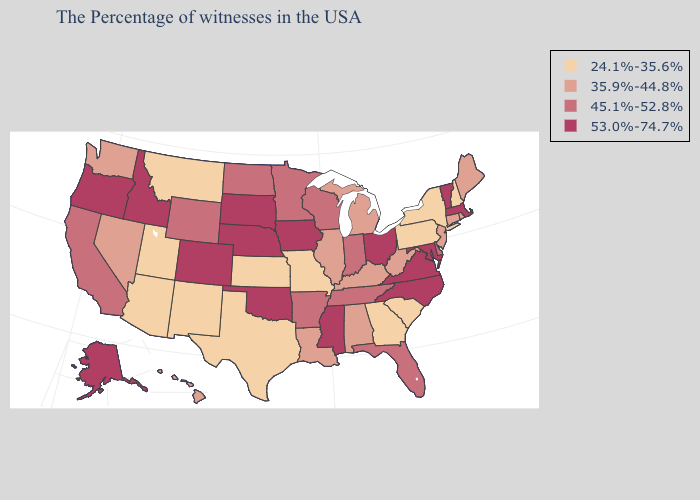What is the value of South Carolina?
Give a very brief answer. 24.1%-35.6%. What is the highest value in the USA?
Be succinct. 53.0%-74.7%. Does New York have the lowest value in the Northeast?
Keep it brief. Yes. Name the states that have a value in the range 45.1%-52.8%?
Quick response, please. Delaware, Florida, Indiana, Tennessee, Wisconsin, Arkansas, Minnesota, North Dakota, Wyoming, California. What is the lowest value in states that border Florida?
Answer briefly. 24.1%-35.6%. What is the lowest value in the South?
Answer briefly. 24.1%-35.6%. How many symbols are there in the legend?
Be succinct. 4. Does Minnesota have the highest value in the MidWest?
Quick response, please. No. Does Massachusetts have the lowest value in the USA?
Keep it brief. No. Which states hav the highest value in the Northeast?
Write a very short answer. Massachusetts, Vermont. What is the value of Texas?
Short answer required. 24.1%-35.6%. What is the value of Montana?
Answer briefly. 24.1%-35.6%. Name the states that have a value in the range 35.9%-44.8%?
Give a very brief answer. Maine, Rhode Island, Connecticut, New Jersey, West Virginia, Michigan, Kentucky, Alabama, Illinois, Louisiana, Nevada, Washington, Hawaii. Name the states that have a value in the range 53.0%-74.7%?
Give a very brief answer. Massachusetts, Vermont, Maryland, Virginia, North Carolina, Ohio, Mississippi, Iowa, Nebraska, Oklahoma, South Dakota, Colorado, Idaho, Oregon, Alaska. Among the states that border New Mexico , does Oklahoma have the highest value?
Be succinct. Yes. 